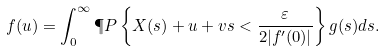<formula> <loc_0><loc_0><loc_500><loc_500>f ( u ) = \int _ { 0 } ^ { \infty } \P P \left \{ X ( s ) + u + v s < \frac { \varepsilon } { 2 | f ^ { \prime } ( 0 ) | } \right \} g ( s ) d s .</formula> 